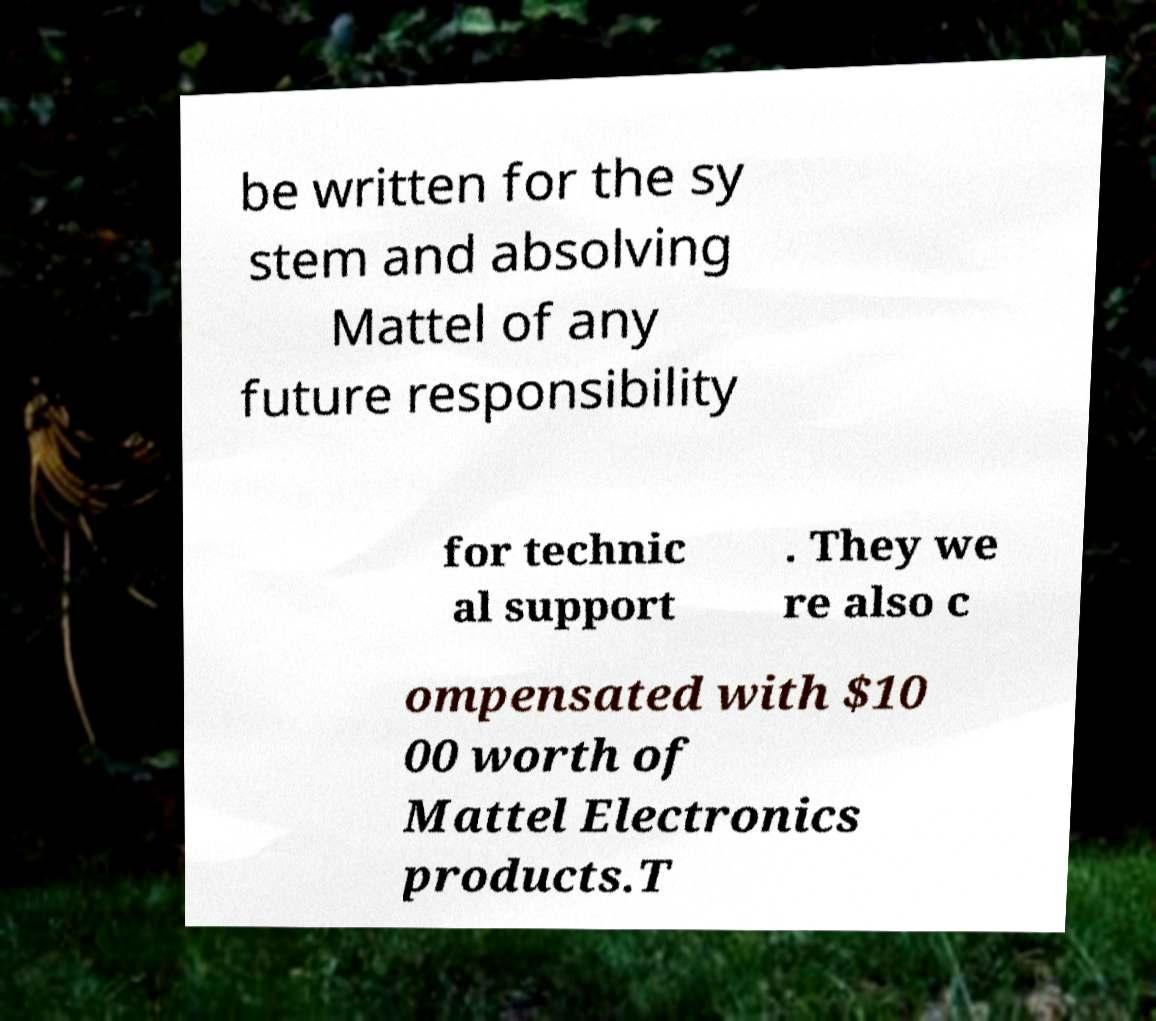Can you accurately transcribe the text from the provided image for me? be written for the sy stem and absolving Mattel of any future responsibility for technic al support . They we re also c ompensated with $10 00 worth of Mattel Electronics products.T 